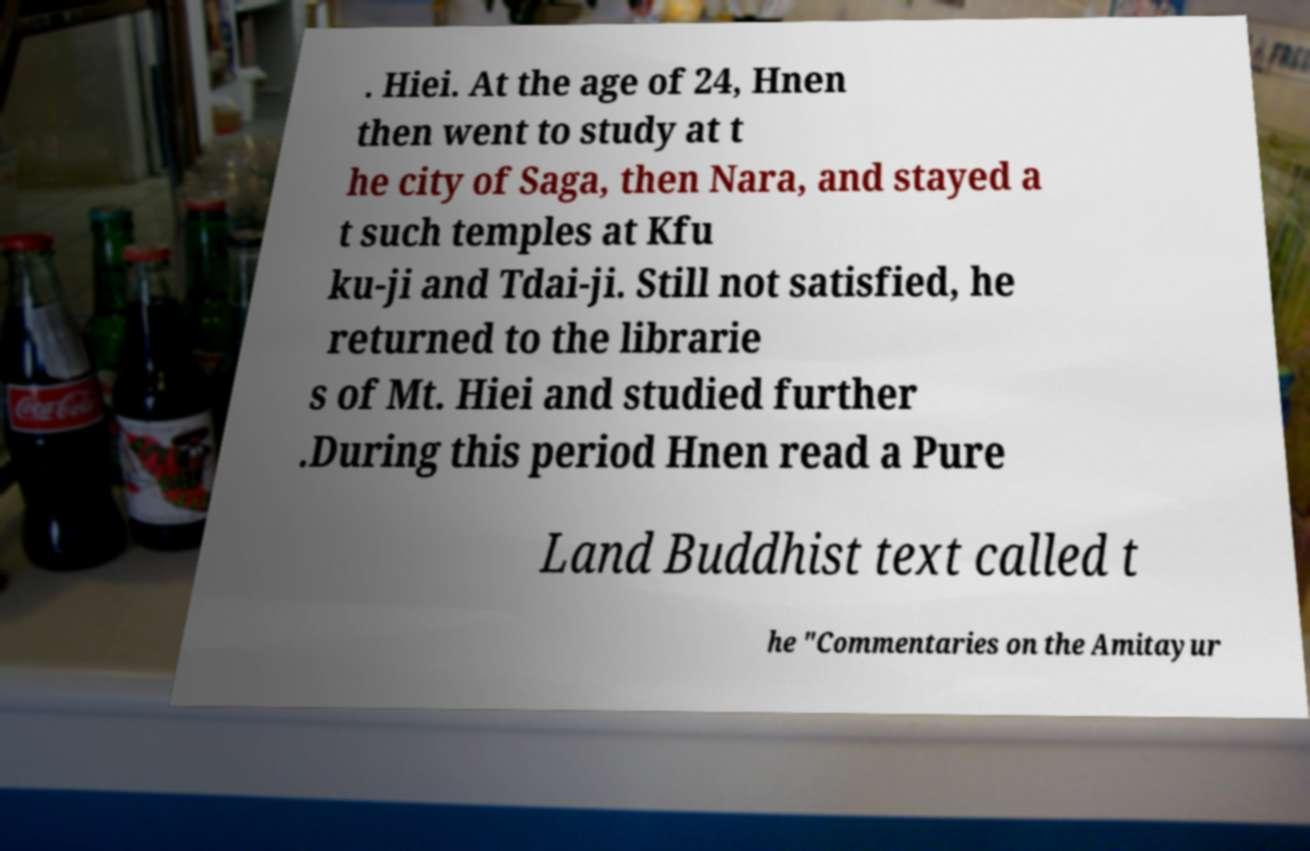Please identify and transcribe the text found in this image. . Hiei. At the age of 24, Hnen then went to study at t he city of Saga, then Nara, and stayed a t such temples at Kfu ku-ji and Tdai-ji. Still not satisfied, he returned to the librarie s of Mt. Hiei and studied further .During this period Hnen read a Pure Land Buddhist text called t he "Commentaries on the Amitayur 